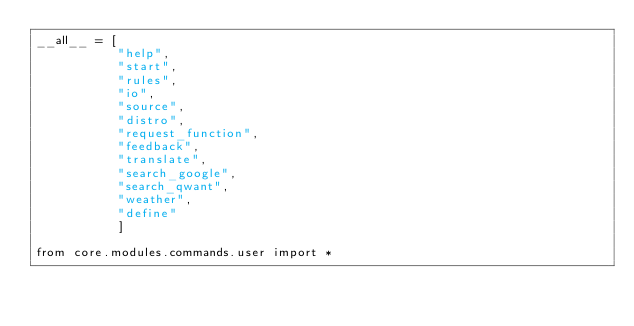Convert code to text. <code><loc_0><loc_0><loc_500><loc_500><_Python_>__all__ = [
           "help", 
           "start", 
           "rules", 
           "io", 
           "source", 
           "distro", 
           "request_function",
           "feedback", 
           "translate",
           "search_google",
           "search_qwant",
           "weather",
           "define"
           ]

from core.modules.commands.user import *</code> 